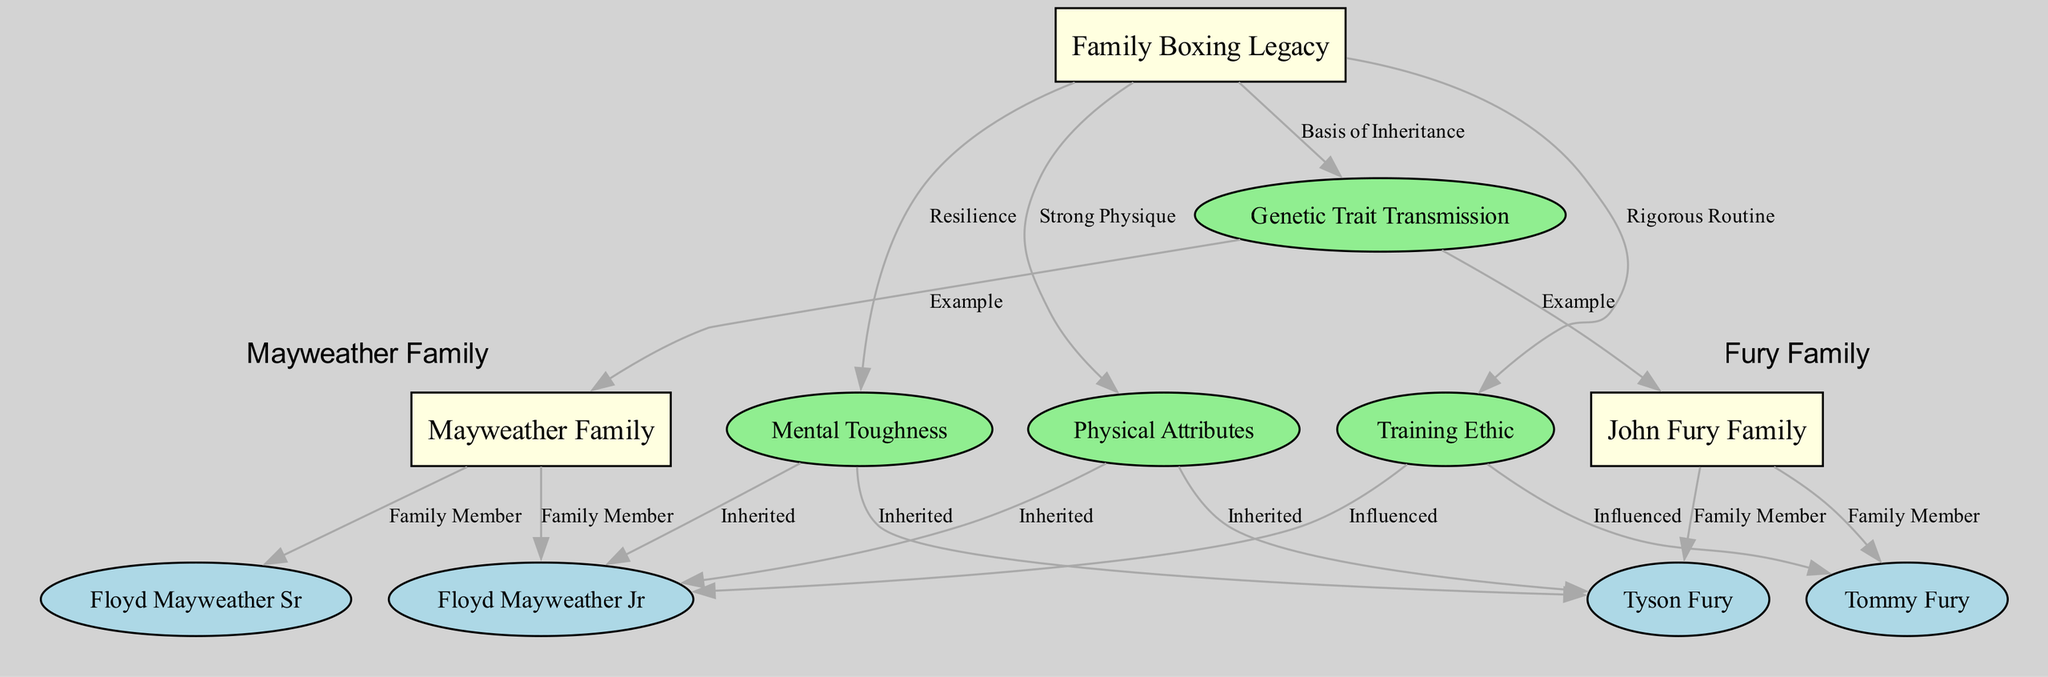What is the main focus of the diagram? The diagram centers around "Family Boxing Legacy," indicating it is concerned with the genetic inheritance of athletic traits within boxing families. The title and highlighted central node provide this key focus area.
Answer: Family Boxing Legacy How many family members are listed under the John Fury Family? The diagram shows two family members specifically listed under the "John Fury Family" node: Tyson Fury and Tommy Fury. A count of the nodes connected to this family node confirms the answer.
Answer: 2 Which attribute is inherited by Floyd Mayweather Jr? The diagram indicates that "Physical Attributes" and "Mental Toughness" are inherited by Floyd Mayweather Jr, as shown by the connections from these nodes to his node. However, the answer seeks one attribute, which is "Physical Attributes."
Answer: Physical Attributes What relationship is shown between training ethic and Tommy Fury? The diagram indicates that Tommy Fury is influenced by the "Training Ethic," as evidenced by the direct edge from "Training Ethic" to "Tommy Fury," labeled "Influenced."
Answer: Influenced Which two families are highlighted in the diagram? The two families featured prominently in the diagram are the John Fury Family and the Mayweather Family, as indicated by their respective nodes and clusters.
Answer: John Fury Family, Mayweather Family How many edges connect to the genetic trait transmission node? The genetic trait transmission node has four edges connecting it to various other nodes, representing the different family examples and the attributes that are passed down. By counting these edges visually or systematically, this can be confirmed.
Answer: 4 Which family member is listed as a member of the Mayweather Family? Floyd Mayweather Jr is specifically listed as a family member under the "Mayweather Family" node, as indicated by the edge labeled "Family Member" connecting him directly to that family node.
Answer: Floyd Mayweather Jr What are the three key attributes associated with Family Boxing Legacy? The diagram outlines three key attributes linked to "Family Boxing Legacy": "Physical Attributes," "Mental Toughness," and "Training Ethic," all represented as direct connections from the legacy node.
Answer: Physical Attributes, Mental Toughness, Training Ethic Who does Mental Toughness directly influence? The "Mental Toughness" node directly influences Tyson Fury and Floyd Mayweather Jr, as shown by the edges labeled "Inherited," indicating that both boxers have inherited this characteristic.
Answer: Tyson Fury, Floyd Mayweather Jr 